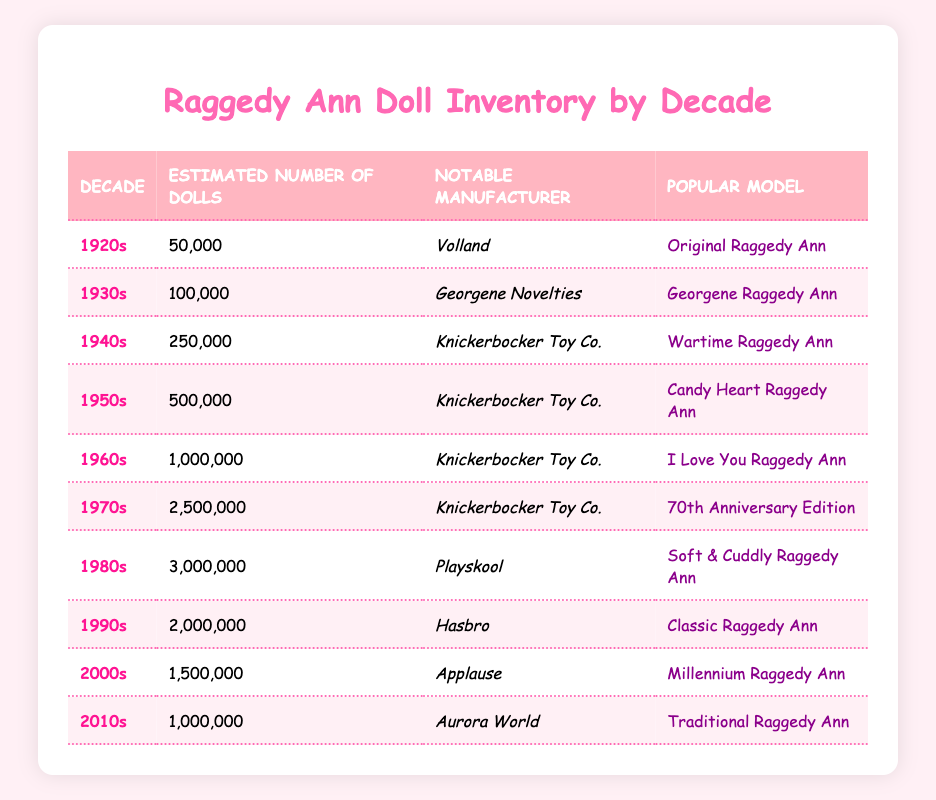What decade produced the most Raggedy Ann dolls? By examining the table, the 1970s has the estimated number of dolls as 2,500,000, which is the highest value when compared to other decades.
Answer: 1970s Which manufacturer produced the Original Raggedy Ann? The Original Raggedy Ann was produced by Volland in the 1920s, as the table indicates.
Answer: Volland How many Raggedy Ann dolls were produced in the 1980s? Referring to the table, the number of dolls produced in the 1980s is listed as 3,000,000.
Answer: 3,000,000 What is the average estimated number of dolls produced from the 1920s to the 1960s? We take the estimated numbers of dolls from these decades (50,000 + 100,000 + 250,000 + 500,000 + 1,000,000) which sums up to 1,900,000. Dividing this by 5 (the number of decades) gives us an average of 380,000.
Answer: 380,000 Is the Hasbro manufacturer known for the Wartime Raggedy Ann model? The table shows that Hasbro produced the Classic Raggedy Ann, while the Wartime Raggedy Ann was produced by Knickerbocker Toy Co., making this statement false.
Answer: No Which popular model was produced by Knickerbocker Toy Co. in the 1950s? According to the table, the popular model produced by Knickerbocker Toy Co. in the 1950s is the Candy Heart Raggedy Ann.
Answer: Candy Heart Raggedy Ann What is the difference in production numbers between the 1960s and the 1990s? From the table, in the 1960s, there were 1,000,000 dolls produced, and in the 1990s, 2,000,000 dolls were produced. The difference is 2,000,000 - 1,000,000 = 1,000,000.
Answer: 1,000,000 Was the Soft & Cuddly Raggedy Ann model produced in the 1970s? The table indicates that the Soft & Cuddly Raggedy Ann model was produced by Playskool in the 1980s, thus this statement is false.
Answer: No Which decade experienced the least production of Raggedy Ann dolls? By reviewing the estimated numbers, the 1920s produced 50,000 dolls, which is the lowest compared to other decades listed in the table.
Answer: 1920s 